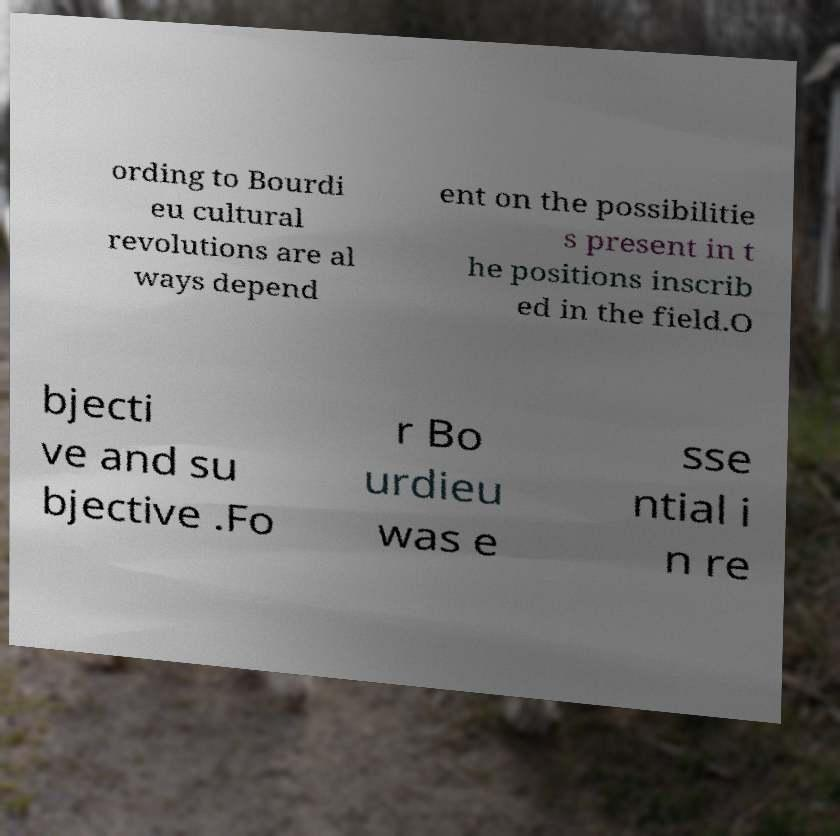There's text embedded in this image that I need extracted. Can you transcribe it verbatim? ording to Bourdi eu cultural revolutions are al ways depend ent on the possibilitie s present in t he positions inscrib ed in the field.O bjecti ve and su bjective .Fo r Bo urdieu was e sse ntial i n re 